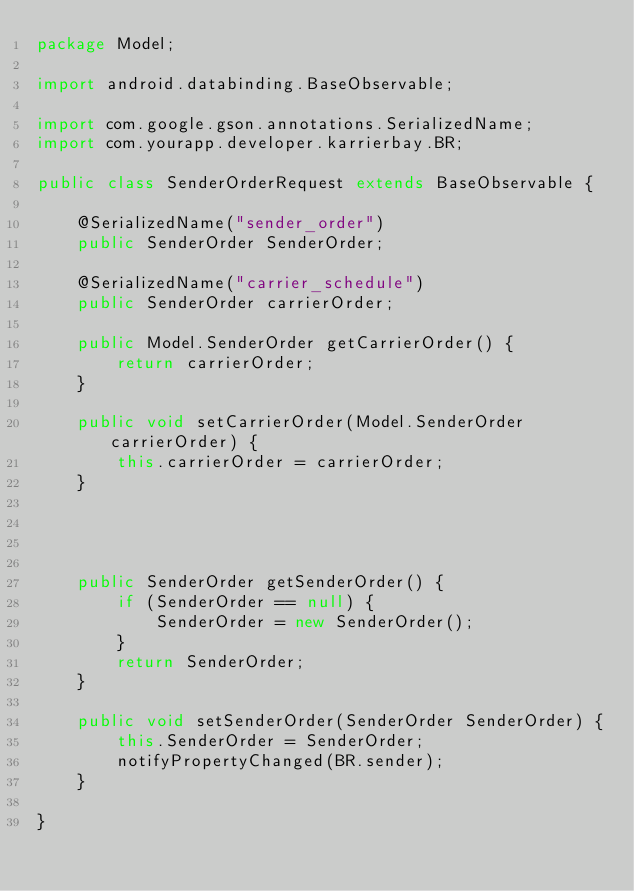Convert code to text. <code><loc_0><loc_0><loc_500><loc_500><_Java_>package Model;

import android.databinding.BaseObservable;

import com.google.gson.annotations.SerializedName;
import com.yourapp.developer.karrierbay.BR;

public class SenderOrderRequest extends BaseObservable {

    @SerializedName("sender_order")
    public SenderOrder SenderOrder;

    @SerializedName("carrier_schedule")
    public SenderOrder carrierOrder;

    public Model.SenderOrder getCarrierOrder() {
        return carrierOrder;
    }

    public void setCarrierOrder(Model.SenderOrder carrierOrder) {
        this.carrierOrder = carrierOrder;
    }




    public SenderOrder getSenderOrder() {
        if (SenderOrder == null) {
            SenderOrder = new SenderOrder();
        }
        return SenderOrder;
    }

    public void setSenderOrder(SenderOrder SenderOrder) {
        this.SenderOrder = SenderOrder;
        notifyPropertyChanged(BR.sender);
    }

}</code> 